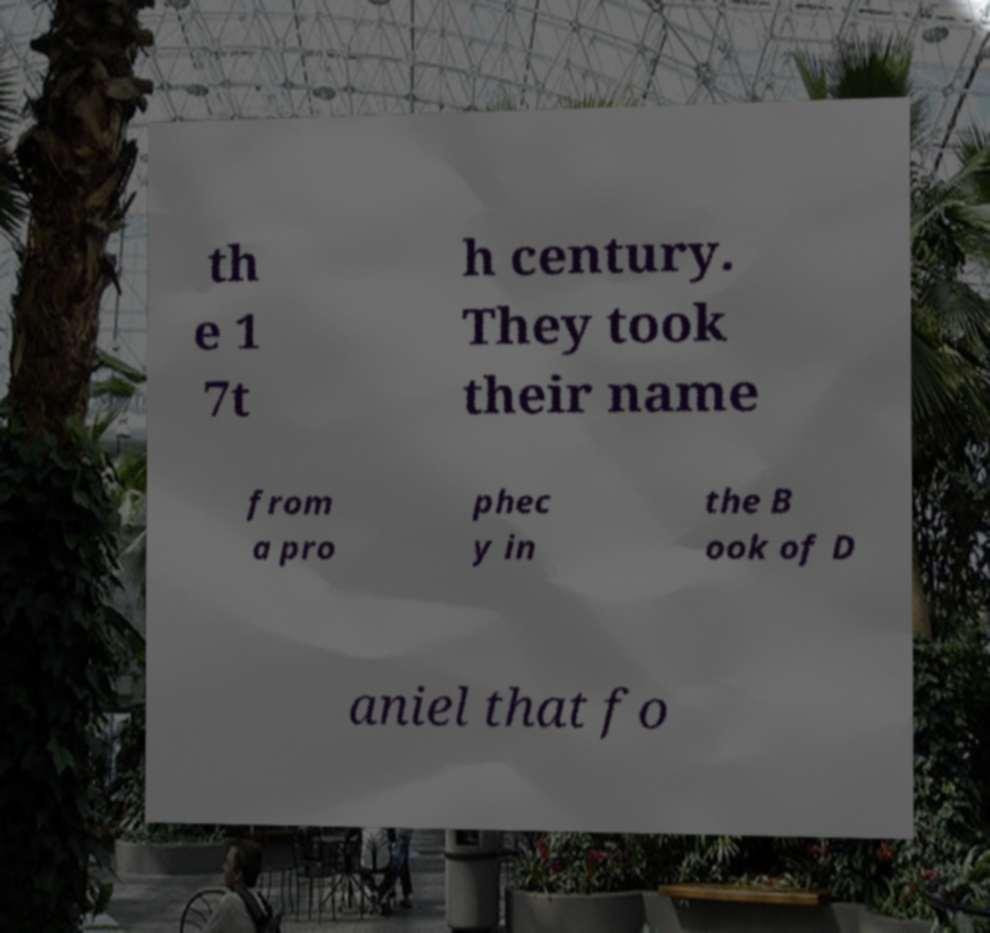For documentation purposes, I need the text within this image transcribed. Could you provide that? th e 1 7t h century. They took their name from a pro phec y in the B ook of D aniel that fo 